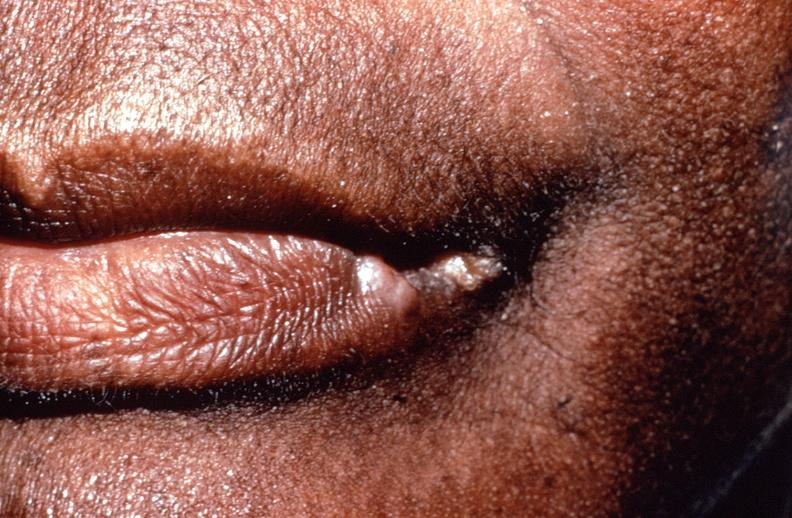what healed?
Answer the question using a single word or phrase. Squamous cell carcinoma 